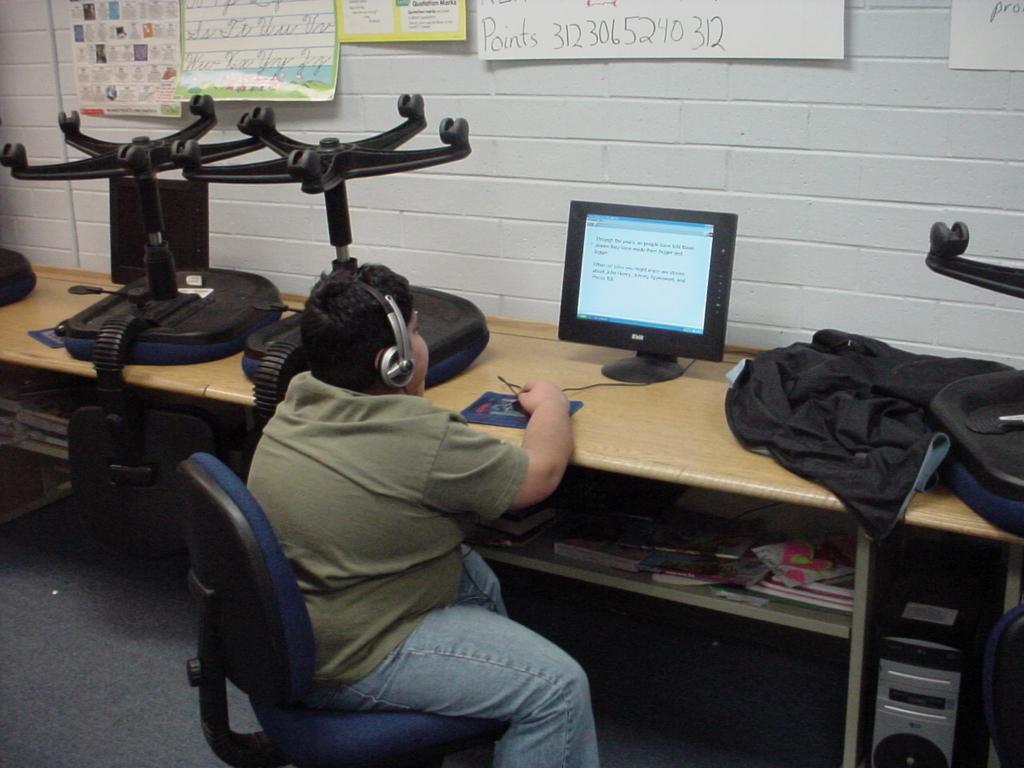In one or two sentences, can you explain what this image depicts? in the center we can see one person sitting on the chair,wearing headphones in front of table. On table we can see monitor,chairs,jacket,books,PC etc. And back we can see wall and on wall we can see charts. 